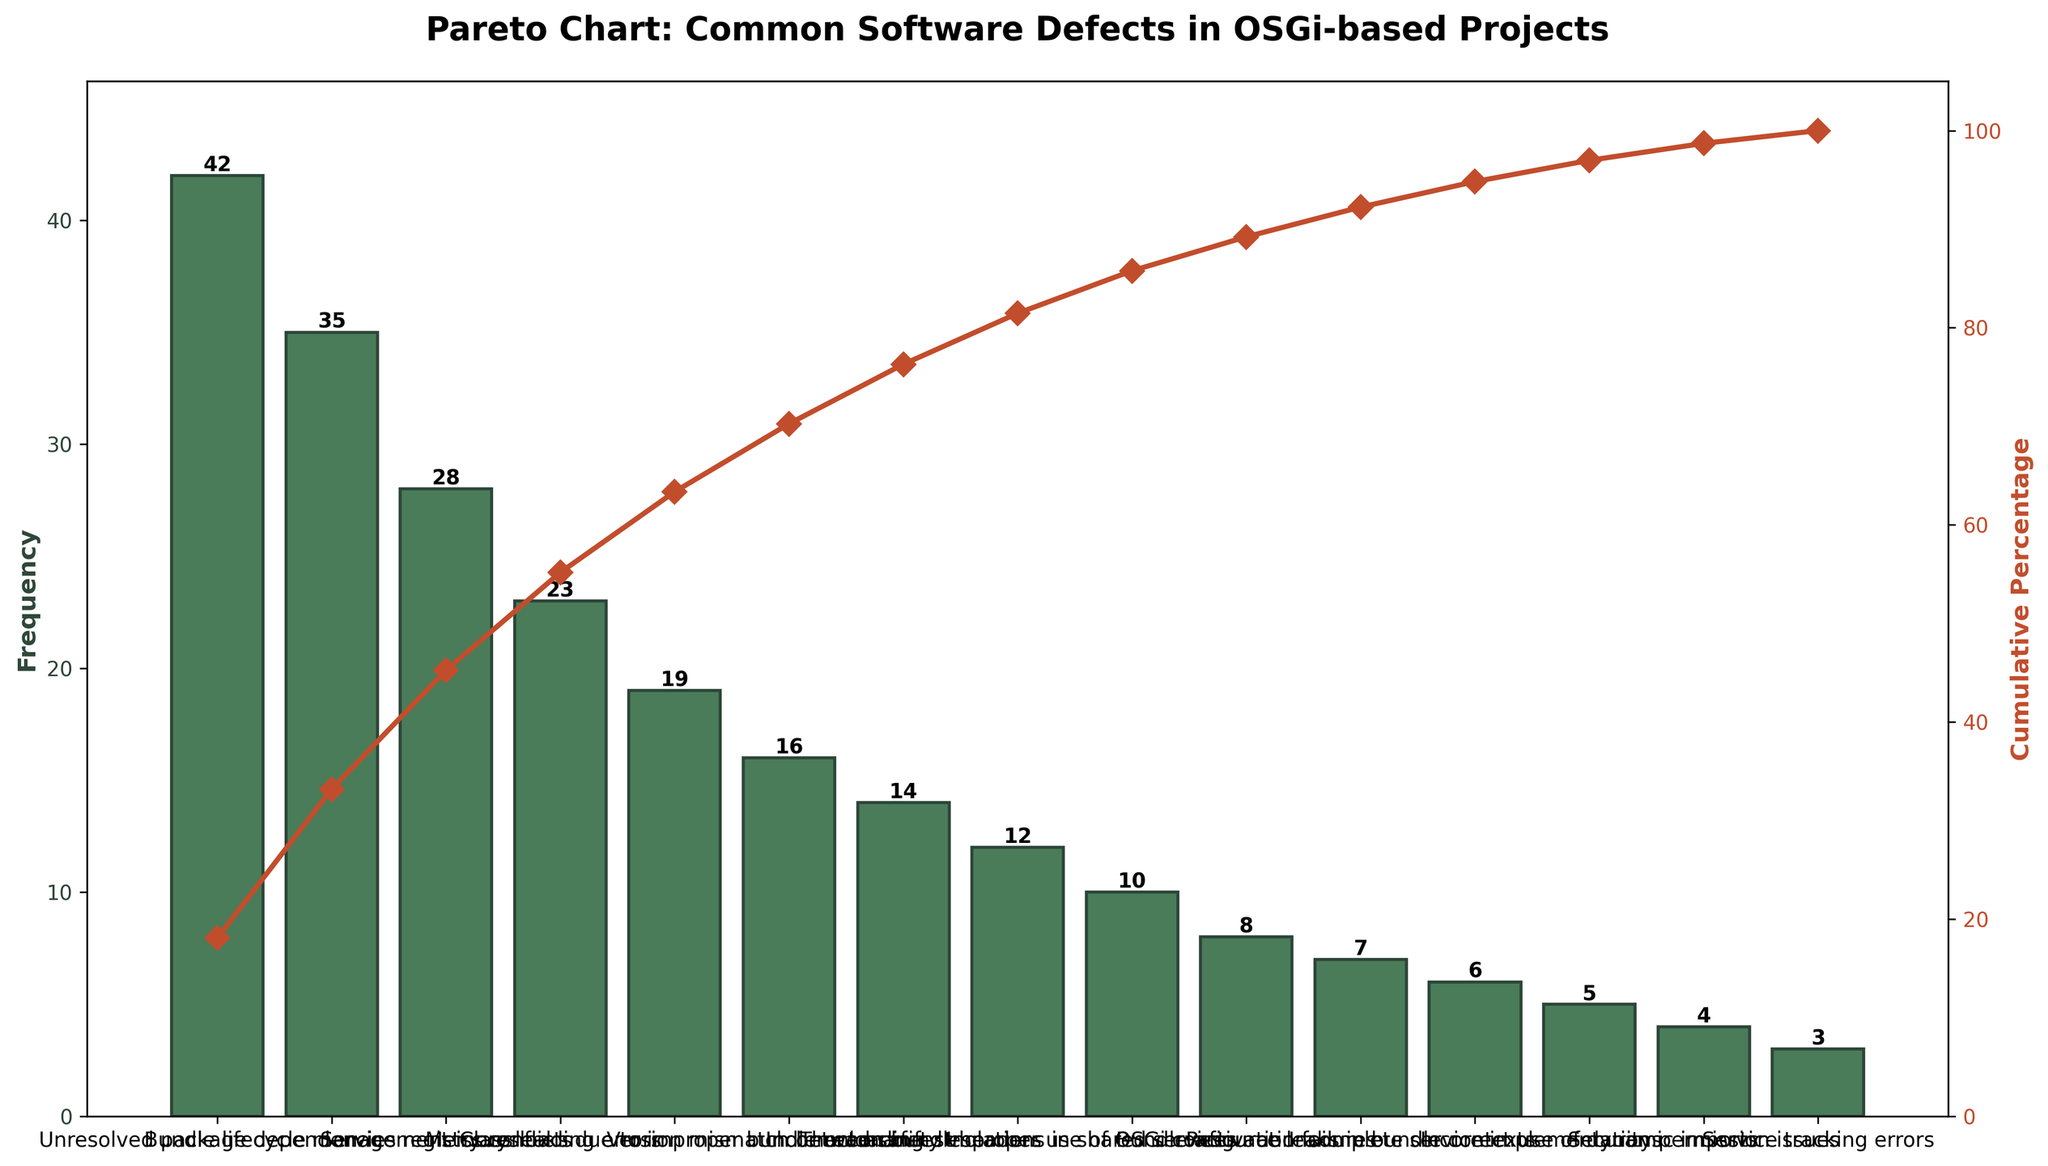What is the title of the figure? The title of the figure is prominently displayed at the top of the chart, and it reads "Pareto Chart: Common Software Defects in OSGi-based Projects".
Answer: Pareto Chart: Common Software Defects in OSGi-based Projects What is the color of the bars representing frequency? The bars representing frequency are shown in the figure in a color that can be described as a dark green.
Answer: Dark green How many types of software defects are represented in the figure? We can count the number of labels along the x-axis to determine the number of defect types. The figure displays 15 different types of software defects.
Answer: 15 What is the defect with the highest frequency? By identifying the tallest bar on the chart, we can see that "Unresolved package dependencies" has the highest frequency.
Answer: Unresolved package dependencies What is the cumulative percentage at the third defect? To find this, look at the cumulative percentage line plotted on the secondary y-axis and locate its value above the third bar. The cumulative percentage for the third defect, "Service registry conflicts," is approximately 63.53%.
Answer: ~63.53% What is the combined frequency of the top two defects? The frequencies of the top two defects are "Unresolved package dependencies" (42) and "Bundle lifecycle management issues" (35). Adding these together gives 42 + 35 = 77.
Answer: 77 How many defects have a frequency less than 20? By counting the bars to the right of the ones with a height indicating a frequency of 20, we can determine that there are seven such defects.
Answer: 7 Which color represents the cumulative percentage line? The line representing cumulative percentage is plotted in a color best described as red.
Answer: Red Is the frequency of 'Memory leaks due to improper bundle unloading' greater than 'Version mismatch between bundles'? By comparing the heights of the bars for these two defects, we see that 'Memory leaks due to improper bundle unloading' (19) is indeed greater than 'Version mismatch between bundles' (16).
Answer: Yes Which defect marks the point where cumulative percentage surpasses 80%? Following the cumulative percentage line above each bar, we observe that 'Incorrect manifest headers' is at the position where the percentage first crosses 80%.
Answer: Incorrect manifest headers 